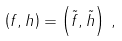Convert formula to latex. <formula><loc_0><loc_0><loc_500><loc_500>\left ( f , h \right ) = \left ( \tilde { f } , \tilde { h } \right ) \, ,</formula> 